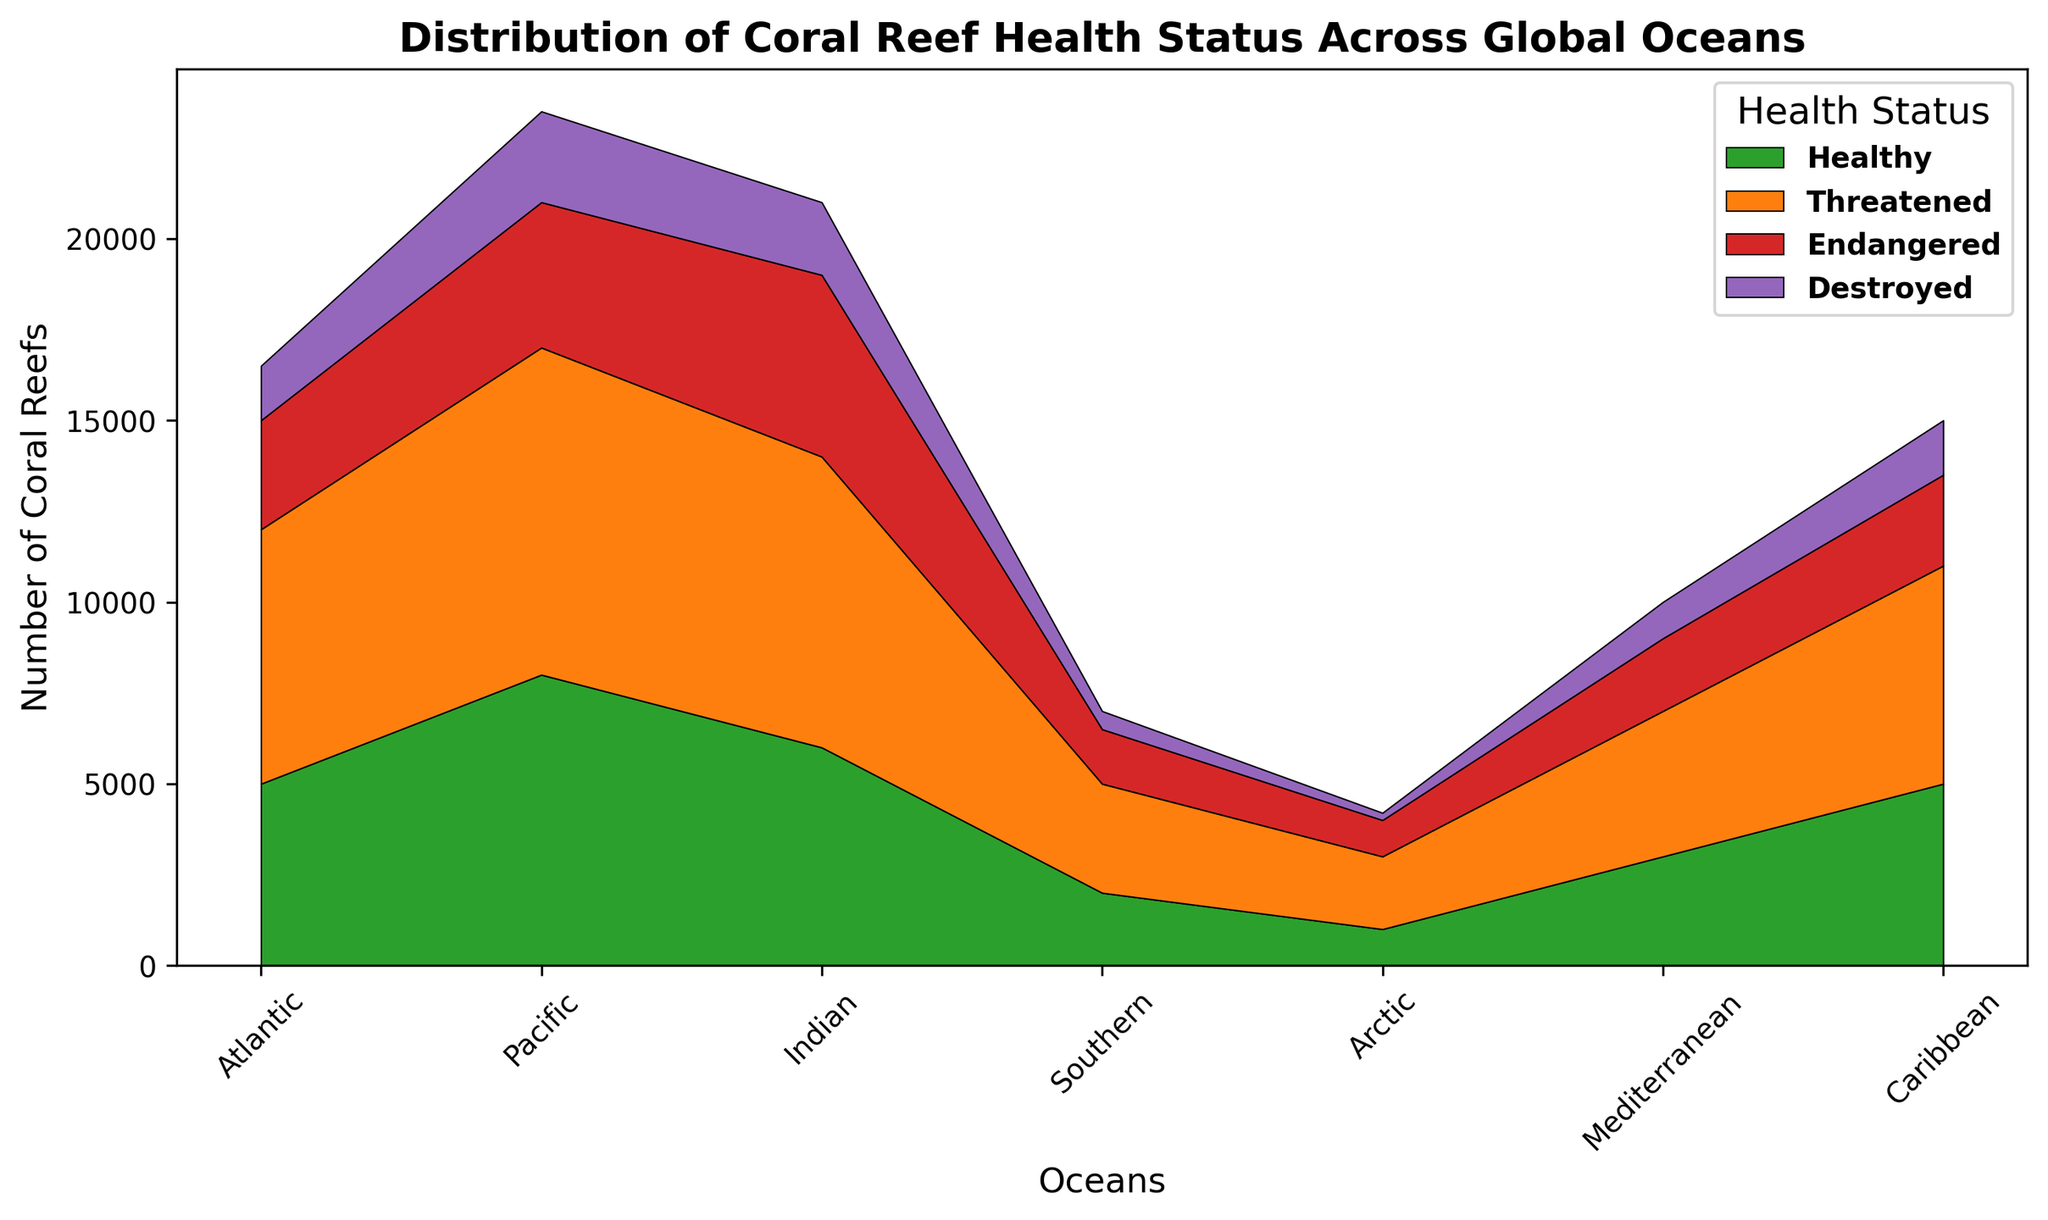What is the total number of coral reefs in the Atlantic Ocean? Summing up the numbers for Healthy (5000), Threatened (7000), Endangered (3000), and Destroyed (1500) corals in the Atlantic Ocean gives: 5000 + 7000 + 3000 + 1500 = 16500
Answer: 16500 Which ocean has the highest number of Healthy coral reefs? Comparing the values of Healthy coral reefs in each ocean: Atlantic (5000), Pacific (8000), Indian (6000), Southern (2000), Arctic (1000), Mediterranean (3000), Caribbean (5000). The Pacific Ocean has the highest number, 8000
Answer: Pacific In which ocean is the difference between Endangered and Destroyed coral reefs the smallest? Calculate the difference for each ocean: Atlantic (3000-1500=1500), Pacific (4000-2500=1500), Indian (5000-2000=3000), Southern (1500-500=1000), Arctic (1000-200=800), Mediterranean (2000-1000=1000), Caribbean (2500-1500=1000). The smallest difference is 800 in the Arctic Ocean
Answer: Arctic What is the difference in the number of Threatened coral reefs between the Pacific and Caribbean oceans? For the Pacific Ocean, Threatened number is 9000, and for the Caribbean, it's 6000. So, the difference is 9000 - 6000 = 3000
Answer: 3000 Which health status category has the most coral reefs across all oceans? Sum up the number for each category across all oceans: Healthy (5000+8000+6000+2000+1000+3000+5000=30000), Threatened(7000+9000+8000+3000+2000+4000+6000=39000), Endangered (3000+4000+5000+1500+1000+2000+2500=19000), Destroyed (1500+2500+2000+500+200+1000+1500=9200). The Threatened category has the highest total, 39000
Answer: Threatened Compare the total number of Endangered coral reefs in the Indian and Caribbean Oceans. Which ocean has more? The Indian Ocean has 5000 Endangered coral reefs, while the Caribbean has 2500. Therefore, the Indian Ocean has more Endangered coral reefs
Answer: Indian By how much do the number of Healthy coral reefs in the Southern Ocean differ from those in the Southern Ocean? Comparing Healthy coral reefs: Southern Ocean (2000) and Arctic Ocean (1000). The difference is 2000 - 1000 = 1000
Answer: 1000 Which ocean has the lowest number of Destroyed coral reefs, and how many are there? Comparing the values: Atlantic (1500), Pacific (2500), Indian (2000), Southern (500), Arctic (200), Mediterranean (1000), Caribbean (1500). The Arctic Ocean has the lowest number, which is 200
Answer: Arctic, 200 What is the total number of coral reefs in the Pacific Ocean categorized as either Endangered or Destroyed? Summing the values for the Pacific Ocean: Endangered (4000) + Destroyed (2500). Total = 4000 + 2500 = 6500
Answer: 6500 